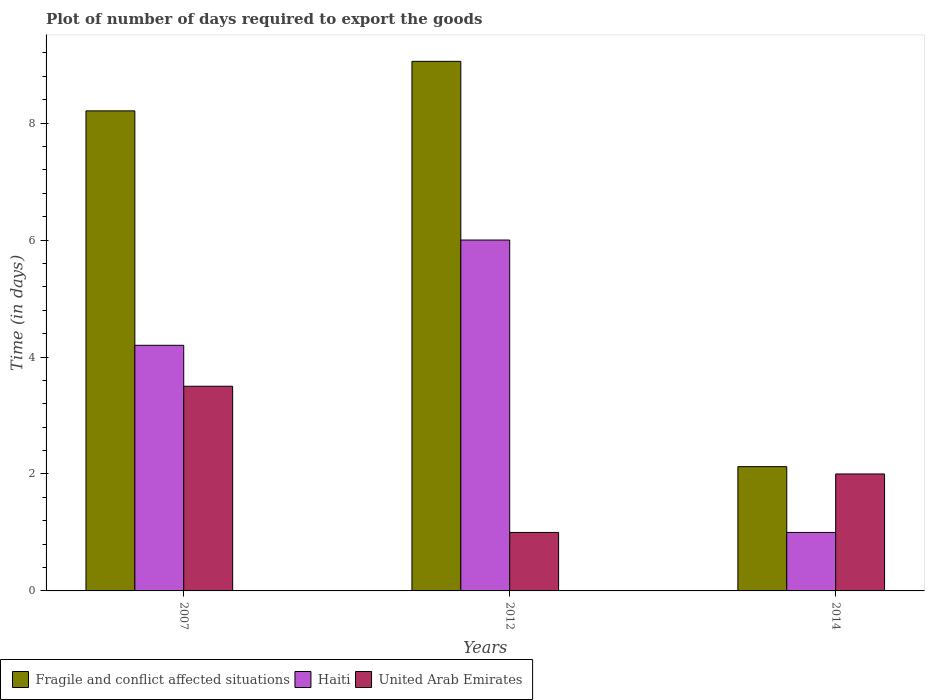How many different coloured bars are there?
Offer a very short reply. 3. How many groups of bars are there?
Your answer should be very brief. 3. Are the number of bars per tick equal to the number of legend labels?
Your answer should be compact. Yes. Are the number of bars on each tick of the X-axis equal?
Your answer should be very brief. Yes. How many bars are there on the 2nd tick from the left?
Provide a succinct answer. 3. How many bars are there on the 3rd tick from the right?
Offer a terse response. 3. What is the label of the 2nd group of bars from the left?
Offer a terse response. 2012. In how many cases, is the number of bars for a given year not equal to the number of legend labels?
Provide a short and direct response. 0. What is the time required to export goods in Haiti in 2012?
Offer a very short reply. 6. Across all years, what is the maximum time required to export goods in Fragile and conflict affected situations?
Make the answer very short. 9.06. Across all years, what is the minimum time required to export goods in Fragile and conflict affected situations?
Keep it short and to the point. 2.12. In which year was the time required to export goods in Fragile and conflict affected situations minimum?
Your response must be concise. 2014. What is the total time required to export goods in Fragile and conflict affected situations in the graph?
Offer a terse response. 19.39. What is the difference between the time required to export goods in United Arab Emirates in 2007 and that in 2014?
Keep it short and to the point. 1.5. What is the difference between the time required to export goods in Fragile and conflict affected situations in 2014 and the time required to export goods in Haiti in 2012?
Make the answer very short. -3.88. What is the average time required to export goods in Fragile and conflict affected situations per year?
Your answer should be compact. 6.46. In the year 2012, what is the difference between the time required to export goods in Fragile and conflict affected situations and time required to export goods in Haiti?
Keep it short and to the point. 3.06. In how many years, is the time required to export goods in Haiti greater than 8.4 days?
Make the answer very short. 0. Is the difference between the time required to export goods in Fragile and conflict affected situations in 2007 and 2014 greater than the difference between the time required to export goods in Haiti in 2007 and 2014?
Give a very brief answer. Yes. What is the difference between the highest and the second highest time required to export goods in Fragile and conflict affected situations?
Make the answer very short. 0.85. What is the difference between the highest and the lowest time required to export goods in Fragile and conflict affected situations?
Give a very brief answer. 6.93. Is the sum of the time required to export goods in United Arab Emirates in 2012 and 2014 greater than the maximum time required to export goods in Haiti across all years?
Your answer should be very brief. No. What does the 1st bar from the left in 2007 represents?
Provide a short and direct response. Fragile and conflict affected situations. What does the 1st bar from the right in 2012 represents?
Offer a very short reply. United Arab Emirates. Is it the case that in every year, the sum of the time required to export goods in Fragile and conflict affected situations and time required to export goods in United Arab Emirates is greater than the time required to export goods in Haiti?
Provide a short and direct response. Yes. How many bars are there?
Give a very brief answer. 9. How many years are there in the graph?
Provide a succinct answer. 3. What is the difference between two consecutive major ticks on the Y-axis?
Keep it short and to the point. 2. How many legend labels are there?
Give a very brief answer. 3. What is the title of the graph?
Provide a short and direct response. Plot of number of days required to export the goods. What is the label or title of the X-axis?
Ensure brevity in your answer.  Years. What is the label or title of the Y-axis?
Offer a terse response. Time (in days). What is the Time (in days) in Fragile and conflict affected situations in 2007?
Your answer should be very brief. 8.21. What is the Time (in days) of Haiti in 2007?
Provide a short and direct response. 4.2. What is the Time (in days) in Fragile and conflict affected situations in 2012?
Your answer should be compact. 9.06. What is the Time (in days) of Haiti in 2012?
Your answer should be very brief. 6. What is the Time (in days) in United Arab Emirates in 2012?
Give a very brief answer. 1. What is the Time (in days) in Fragile and conflict affected situations in 2014?
Offer a very short reply. 2.12. Across all years, what is the maximum Time (in days) in Fragile and conflict affected situations?
Offer a terse response. 9.06. Across all years, what is the maximum Time (in days) in Haiti?
Offer a very short reply. 6. Across all years, what is the minimum Time (in days) in Fragile and conflict affected situations?
Ensure brevity in your answer.  2.12. Across all years, what is the minimum Time (in days) of United Arab Emirates?
Provide a short and direct response. 1. What is the total Time (in days) in Fragile and conflict affected situations in the graph?
Make the answer very short. 19.39. What is the total Time (in days) in Haiti in the graph?
Keep it short and to the point. 11.2. What is the total Time (in days) of United Arab Emirates in the graph?
Your answer should be very brief. 6.5. What is the difference between the Time (in days) of Fragile and conflict affected situations in 2007 and that in 2012?
Provide a succinct answer. -0.85. What is the difference between the Time (in days) in Haiti in 2007 and that in 2012?
Ensure brevity in your answer.  -1.8. What is the difference between the Time (in days) in Fragile and conflict affected situations in 2007 and that in 2014?
Your answer should be very brief. 6.08. What is the difference between the Time (in days) of Haiti in 2007 and that in 2014?
Offer a very short reply. 3.2. What is the difference between the Time (in days) in United Arab Emirates in 2007 and that in 2014?
Offer a very short reply. 1.5. What is the difference between the Time (in days) of Fragile and conflict affected situations in 2012 and that in 2014?
Your answer should be compact. 6.93. What is the difference between the Time (in days) in United Arab Emirates in 2012 and that in 2014?
Make the answer very short. -1. What is the difference between the Time (in days) in Fragile and conflict affected situations in 2007 and the Time (in days) in Haiti in 2012?
Your response must be concise. 2.21. What is the difference between the Time (in days) in Fragile and conflict affected situations in 2007 and the Time (in days) in United Arab Emirates in 2012?
Your answer should be compact. 7.21. What is the difference between the Time (in days) in Fragile and conflict affected situations in 2007 and the Time (in days) in Haiti in 2014?
Ensure brevity in your answer.  7.21. What is the difference between the Time (in days) in Fragile and conflict affected situations in 2007 and the Time (in days) in United Arab Emirates in 2014?
Offer a terse response. 6.21. What is the difference between the Time (in days) in Fragile and conflict affected situations in 2012 and the Time (in days) in Haiti in 2014?
Offer a terse response. 8.06. What is the difference between the Time (in days) of Fragile and conflict affected situations in 2012 and the Time (in days) of United Arab Emirates in 2014?
Keep it short and to the point. 7.06. What is the difference between the Time (in days) in Haiti in 2012 and the Time (in days) in United Arab Emirates in 2014?
Offer a terse response. 4. What is the average Time (in days) in Fragile and conflict affected situations per year?
Your answer should be compact. 6.46. What is the average Time (in days) in Haiti per year?
Provide a short and direct response. 3.73. What is the average Time (in days) of United Arab Emirates per year?
Your answer should be very brief. 2.17. In the year 2007, what is the difference between the Time (in days) in Fragile and conflict affected situations and Time (in days) in Haiti?
Ensure brevity in your answer.  4.01. In the year 2007, what is the difference between the Time (in days) in Fragile and conflict affected situations and Time (in days) in United Arab Emirates?
Provide a succinct answer. 4.71. In the year 2007, what is the difference between the Time (in days) of Haiti and Time (in days) of United Arab Emirates?
Offer a very short reply. 0.7. In the year 2012, what is the difference between the Time (in days) in Fragile and conflict affected situations and Time (in days) in Haiti?
Give a very brief answer. 3.06. In the year 2012, what is the difference between the Time (in days) in Fragile and conflict affected situations and Time (in days) in United Arab Emirates?
Your answer should be compact. 8.06. In the year 2014, what is the difference between the Time (in days) of Fragile and conflict affected situations and Time (in days) of Haiti?
Give a very brief answer. 1.12. In the year 2014, what is the difference between the Time (in days) of Fragile and conflict affected situations and Time (in days) of United Arab Emirates?
Your answer should be compact. 0.12. In the year 2014, what is the difference between the Time (in days) in Haiti and Time (in days) in United Arab Emirates?
Your response must be concise. -1. What is the ratio of the Time (in days) in Fragile and conflict affected situations in 2007 to that in 2012?
Your response must be concise. 0.91. What is the ratio of the Time (in days) of Fragile and conflict affected situations in 2007 to that in 2014?
Ensure brevity in your answer.  3.86. What is the ratio of the Time (in days) of Haiti in 2007 to that in 2014?
Provide a succinct answer. 4.2. What is the ratio of the Time (in days) of Fragile and conflict affected situations in 2012 to that in 2014?
Ensure brevity in your answer.  4.26. What is the ratio of the Time (in days) in Haiti in 2012 to that in 2014?
Offer a very short reply. 6. What is the ratio of the Time (in days) in United Arab Emirates in 2012 to that in 2014?
Your response must be concise. 0.5. What is the difference between the highest and the second highest Time (in days) in Fragile and conflict affected situations?
Provide a short and direct response. 0.85. What is the difference between the highest and the lowest Time (in days) of Fragile and conflict affected situations?
Give a very brief answer. 6.93. 